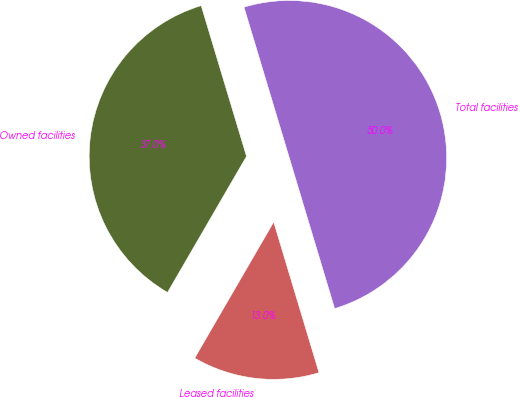Convert chart to OTSL. <chart><loc_0><loc_0><loc_500><loc_500><pie_chart><fcel>Owned facilities<fcel>Leased facilities<fcel>Total facilities<nl><fcel>36.98%<fcel>13.02%<fcel>50.0%<nl></chart> 